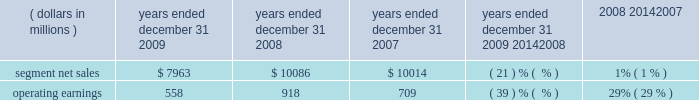Management 2019s discussion and analysis of financial condition and results of operations in 2008 , asp was flat compared to 2007 .
By comparison , asp decreased approximately 9% ( 9 % ) in 2007 and decreased approximately 11% ( 11 % ) in 2006 .
The segment has several large customers located throughout the world .
In 2008 , aggregate net sales to the segment 2019s five largest customers accounted for approximately 41% ( 41 % ) of the segment 2019s net sales .
Besides selling directly to carriers and operators , the segment also sells products through a variety of third-party distributors and retailers , which accounted for approximately 24% ( 24 % ) of the segment 2019s net sales in 2008 .
Although the u.s .
Market continued to be the segment 2019s largest individual market , many of our customers , and 56% ( 56 % ) of the segment 2019s 2008 net sales , were outside the u.s .
In 2008 , the largest of these international markets were brazil , china and mexico .
As the segment 2019s revenue transactions are largely denominated in local currencies , we are impacted by the weakening in the value of these local currencies against the u.s .
Dollar .
A number of our more significant international markets , particularly in latin america , were impacted by this trend in late 2008 .
Home and networks mobility segment the home and networks mobility segment designs , manufactures , sells , installs and services : ( i ) digital video , internet protocol video and broadcast network interactive set-tops , end-to-end video distribution systems , broadband access infrastructure platforms , and associated data and voice customer premise equipment to cable television and telecom service providers ( collectively , referred to as the 2018 2018home business 2019 2019 ) , and ( ii ) wireless access systems , including cellular infrastructure systems and wireless broadband systems , to wireless service providers ( collectively , referred to as the 2018 2018network business 2019 2019 ) .
In 2009 , the segment 2019s net sales represented 36% ( 36 % ) of the company 2019s consolidated net sales , compared to 33% ( 33 % ) in 2008 and 27% ( 27 % ) in 2007 .
Years ended december 31 percent change ( dollars in millions ) 2009 2008 2007 2009 20142008 2008 20142007 .
Segment results 20142009 compared to 2008 in 2009 , the segment 2019s net sales were $ 8.0 billion , a decrease of 21% ( 21 % ) compared to net sales of $ 10.1 billion in 2008 .
The 21% ( 21 % ) decrease in net sales reflects a 22% ( 22 % ) decrease in net sales in the networks business and a 21% ( 21 % ) decrease in net sales in the home business .
The 22% ( 22 % ) decrease in net sales in the networks business was primarily driven by lower net sales of gsm , cdma , umts and iden infrastructure equipment , partially offset by higher net sales of wimax products .
The 21% ( 21 % ) decrease in net sales in the home business was primarily driven by a 24% ( 24 % ) decrease in net sales of digital entertainment devices , reflecting : ( i ) an 18% ( 18 % ) decrease in shipments of digital entertainment devices , primarily due to lower shipments to large cable and telecommunications operators in north america as a result of macroeconomic conditions , and ( ii ) a lower asp due to an unfavorable shift in product mix .
The segment shipped 14.7 million digital entertainment devices in 2009 , compared to 18.0 million shipped in 2008 .
On a geographic basis , the 21% ( 21 % ) decrease in net sales was driven by lower net sales in all regions .
The decrease in net sales in north america was primarily due to : ( i ) lower net sales in the home business , and ( ii ) lower net sales of cdma and iden infrastructure equipment , partially offset by higher net sales of wimax products .
The decrease in net sales in emea was primarily due to lower net sales of gsm infrastructure equipment , partially offset by higher net sales of wimax products and higher net sales in the home business .
The decrease in net sales in asia was primarily driven by lower net sales of gsm , umts and cdma infrastructure equipment , partially offset by higher net sales in the home business .
The decrease in net sales in latin america was primarily due to : ( i ) lower net sales in the home business , and ( ii ) lower net sales of iden infrastructure equipment , partially offset by higher net sales of wimax products .
Net sales in north america accounted for approximately 51% ( 51 % ) of the segment 2019s total net sales in 2009 , compared to approximately 50% ( 50 % ) of the segment 2019s total net sales in 2008. .
What was the average segment net sales from 2007 to 2009 in millions? 
Computations: (((10014 + (7963 + 10086)) + 3) / 2)
Answer: 14033.0. 